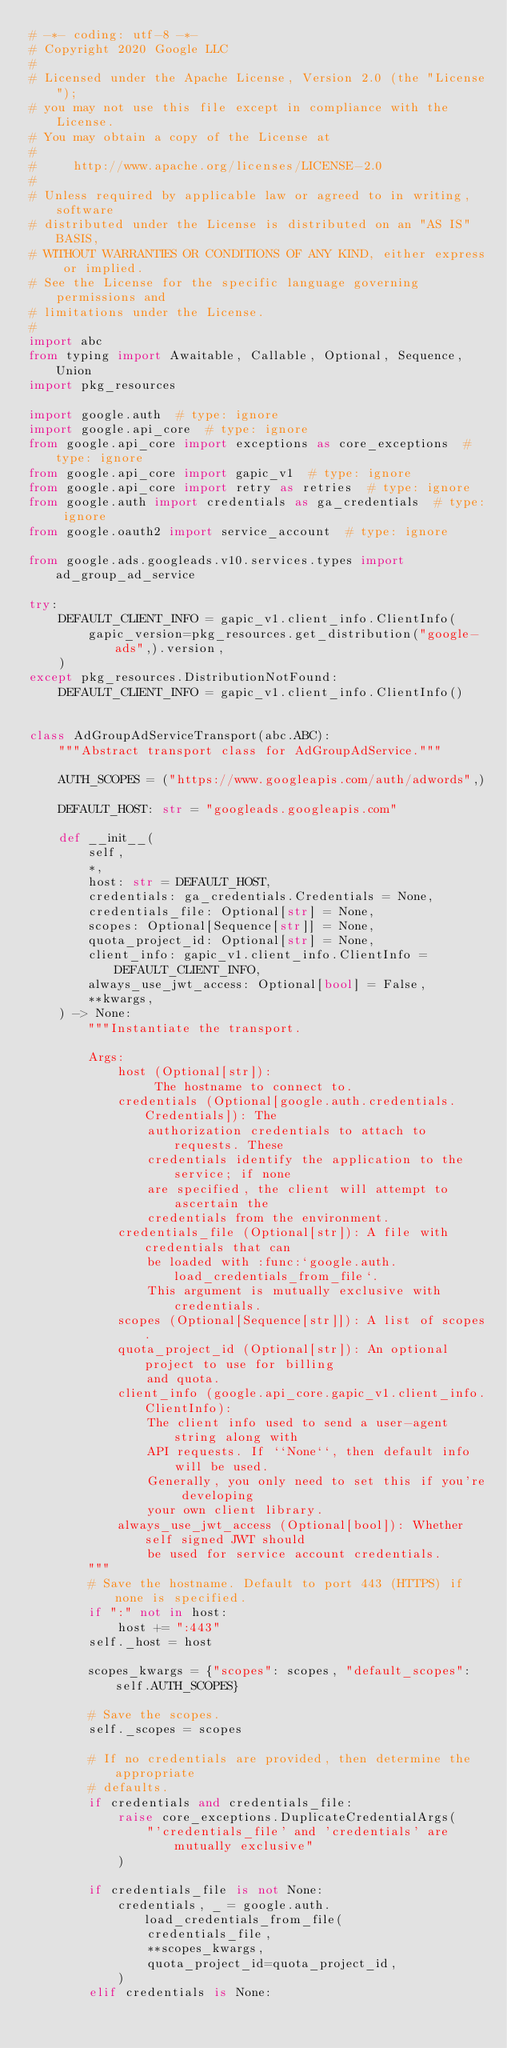<code> <loc_0><loc_0><loc_500><loc_500><_Python_># -*- coding: utf-8 -*-
# Copyright 2020 Google LLC
#
# Licensed under the Apache License, Version 2.0 (the "License");
# you may not use this file except in compliance with the License.
# You may obtain a copy of the License at
#
#     http://www.apache.org/licenses/LICENSE-2.0
#
# Unless required by applicable law or agreed to in writing, software
# distributed under the License is distributed on an "AS IS" BASIS,
# WITHOUT WARRANTIES OR CONDITIONS OF ANY KIND, either express or implied.
# See the License for the specific language governing permissions and
# limitations under the License.
#
import abc
from typing import Awaitable, Callable, Optional, Sequence, Union
import pkg_resources

import google.auth  # type: ignore
import google.api_core  # type: ignore
from google.api_core import exceptions as core_exceptions  # type: ignore
from google.api_core import gapic_v1  # type: ignore
from google.api_core import retry as retries  # type: ignore
from google.auth import credentials as ga_credentials  # type: ignore
from google.oauth2 import service_account  # type: ignore

from google.ads.googleads.v10.services.types import ad_group_ad_service

try:
    DEFAULT_CLIENT_INFO = gapic_v1.client_info.ClientInfo(
        gapic_version=pkg_resources.get_distribution("google-ads",).version,
    )
except pkg_resources.DistributionNotFound:
    DEFAULT_CLIENT_INFO = gapic_v1.client_info.ClientInfo()


class AdGroupAdServiceTransport(abc.ABC):
    """Abstract transport class for AdGroupAdService."""

    AUTH_SCOPES = ("https://www.googleapis.com/auth/adwords",)

    DEFAULT_HOST: str = "googleads.googleapis.com"

    def __init__(
        self,
        *,
        host: str = DEFAULT_HOST,
        credentials: ga_credentials.Credentials = None,
        credentials_file: Optional[str] = None,
        scopes: Optional[Sequence[str]] = None,
        quota_project_id: Optional[str] = None,
        client_info: gapic_v1.client_info.ClientInfo = DEFAULT_CLIENT_INFO,
        always_use_jwt_access: Optional[bool] = False,
        **kwargs,
    ) -> None:
        """Instantiate the transport.

        Args:
            host (Optional[str]):
                 The hostname to connect to.
            credentials (Optional[google.auth.credentials.Credentials]): The
                authorization credentials to attach to requests. These
                credentials identify the application to the service; if none
                are specified, the client will attempt to ascertain the
                credentials from the environment.
            credentials_file (Optional[str]): A file with credentials that can
                be loaded with :func:`google.auth.load_credentials_from_file`.
                This argument is mutually exclusive with credentials.
            scopes (Optional[Sequence[str]]): A list of scopes.
            quota_project_id (Optional[str]): An optional project to use for billing
                and quota.
            client_info (google.api_core.gapic_v1.client_info.ClientInfo):
                The client info used to send a user-agent string along with
                API requests. If ``None``, then default info will be used.
                Generally, you only need to set this if you're developing
                your own client library.
            always_use_jwt_access (Optional[bool]): Whether self signed JWT should
                be used for service account credentials.
        """
        # Save the hostname. Default to port 443 (HTTPS) if none is specified.
        if ":" not in host:
            host += ":443"
        self._host = host

        scopes_kwargs = {"scopes": scopes, "default_scopes": self.AUTH_SCOPES}

        # Save the scopes.
        self._scopes = scopes

        # If no credentials are provided, then determine the appropriate
        # defaults.
        if credentials and credentials_file:
            raise core_exceptions.DuplicateCredentialArgs(
                "'credentials_file' and 'credentials' are mutually exclusive"
            )

        if credentials_file is not None:
            credentials, _ = google.auth.load_credentials_from_file(
                credentials_file,
                **scopes_kwargs,
                quota_project_id=quota_project_id,
            )
        elif credentials is None:</code> 